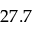Convert formula to latex. <formula><loc_0><loc_0><loc_500><loc_500>2 7 . 7</formula> 